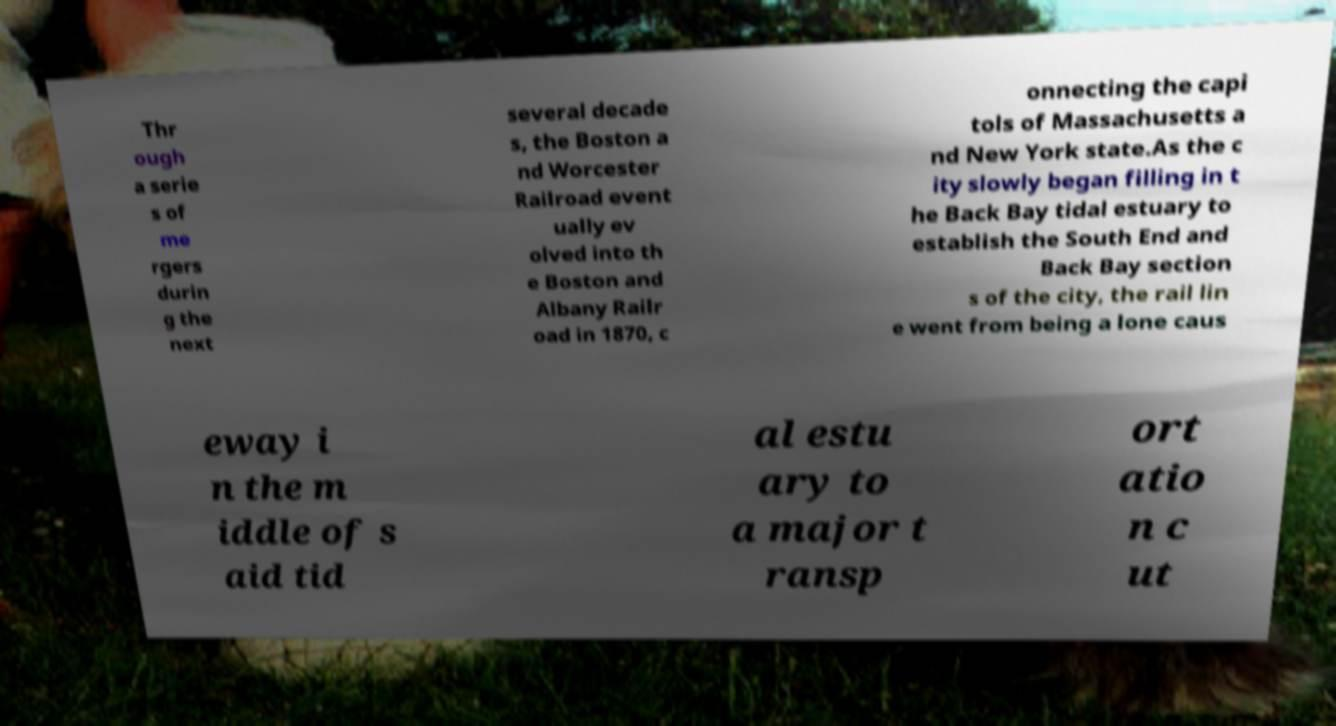Please read and relay the text visible in this image. What does it say? Thr ough a serie s of me rgers durin g the next several decade s, the Boston a nd Worcester Railroad event ually ev olved into th e Boston and Albany Railr oad in 1870, c onnecting the capi tols of Massachusetts a nd New York state.As the c ity slowly began filling in t he Back Bay tidal estuary to establish the South End and Back Bay section s of the city, the rail lin e went from being a lone caus eway i n the m iddle of s aid tid al estu ary to a major t ransp ort atio n c ut 